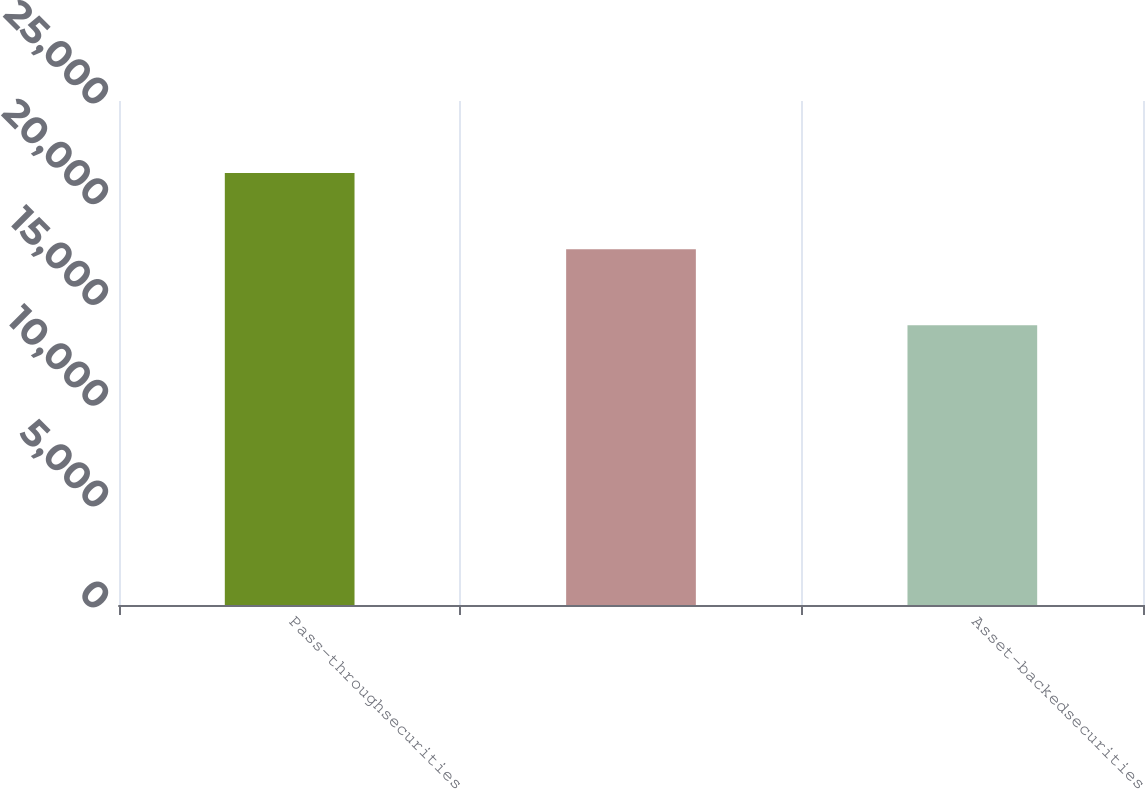Convert chart to OTSL. <chart><loc_0><loc_0><loc_500><loc_500><bar_chart><fcel>Pass-throughsecurities<fcel>Unnamed: 1<fcel>Asset-backedsecurities<nl><fcel>21431.6<fcel>17652.3<fcel>13873<nl></chart> 